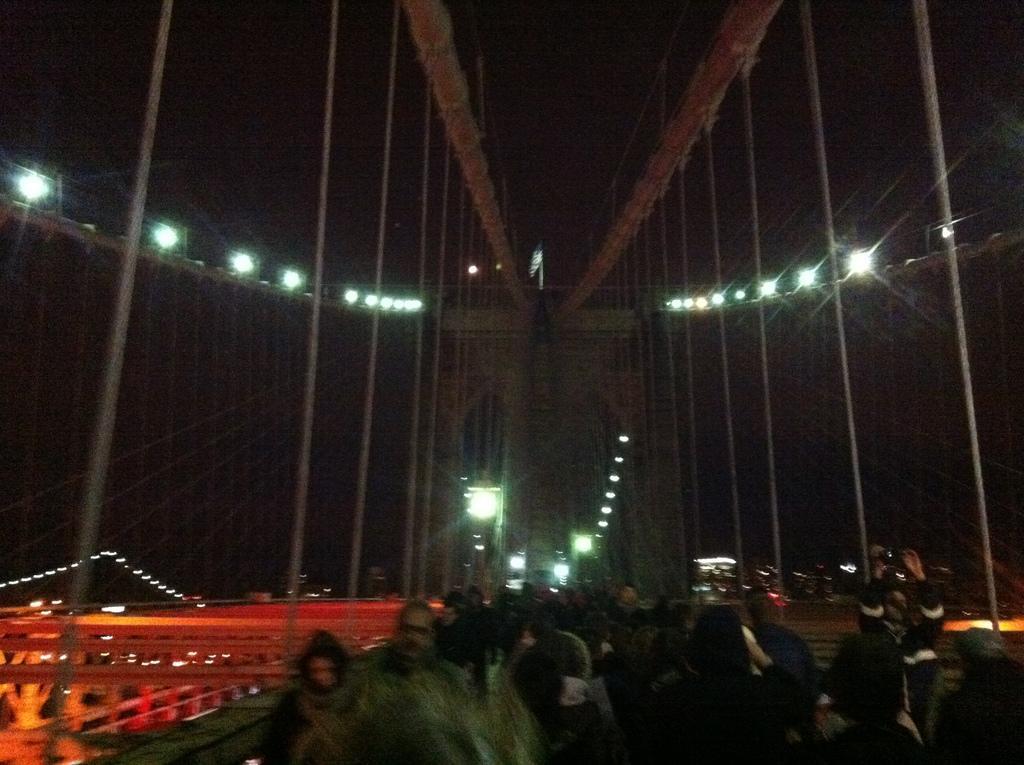How would you summarize this image in a sentence or two? In this picture we can see people on a bridge. We can see ropes. Background portion of the picture is completely dark. We can see lights. On the left side of the picture we can see objects. 